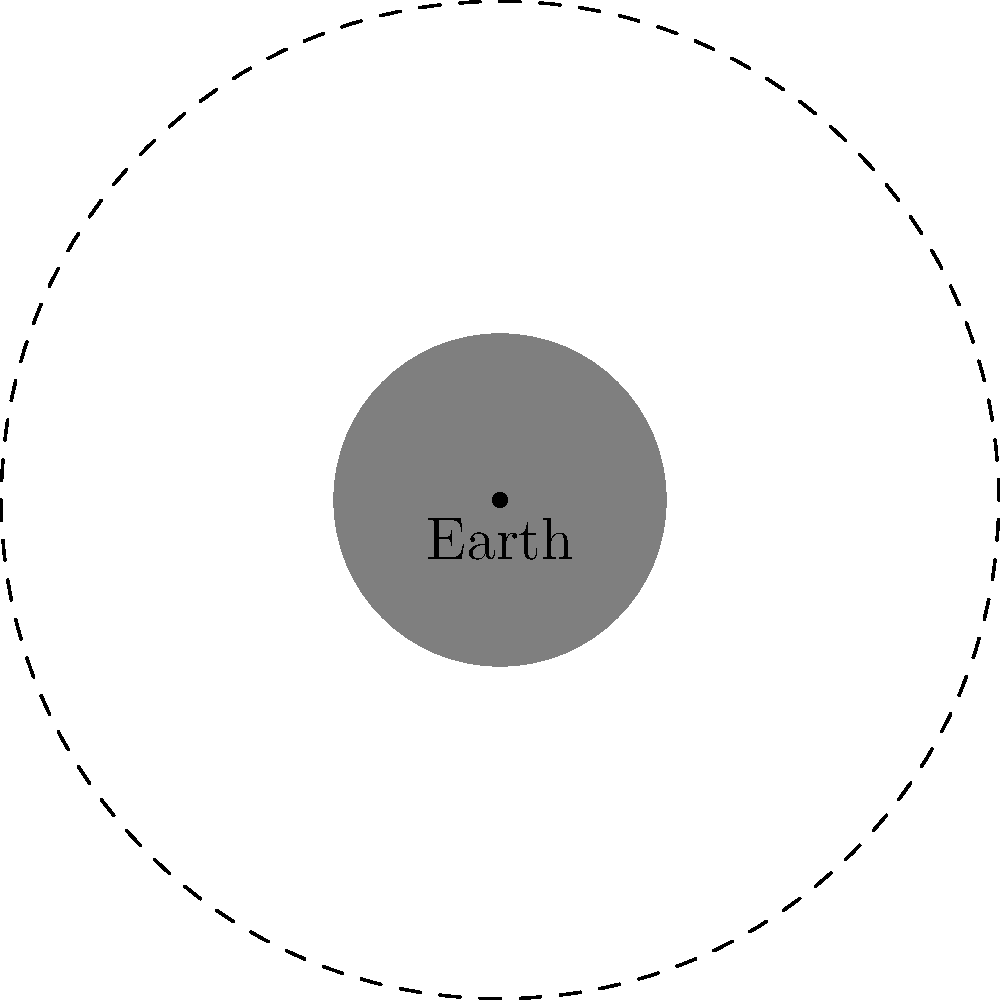As a convenience store owner who often chats with customers about various topics, you've noticed some confusion about the Moon's phases. Looking at the diagram, which phase of the Moon would appear as a half-circle illuminated on the right side when viewed from Earth? Let's break this down step-by-step:

1. The diagram shows the Earth at the center and the Moon's orbit around it.

2. The Sun's light is coming from the right side of the diagram, as indicated by the arrow.

3. There are four Moon positions shown, representing the main phases:
   - New Moon: completely dark (on the right)
   - First Quarter: right half illuminated (at the top)
   - Full Moon: completely illuminated (on the left)
   - Last Quarter: left half illuminated (at the bottom)

4. When we see a half-circle illuminated, it's either the First Quarter or Last Quarter phase.

5. The question asks for the phase where the right side is illuminated.

6. Looking at the diagram, this occurs when the Moon is at the top position, labeled "First Quarter".

7. In this position, the right half of the Moon (from Earth's perspective) is facing the Sun and thus illuminated.

Therefore, the phase that appears as a half-circle illuminated on the right side when viewed from Earth is the First Quarter moon.
Answer: First Quarter 